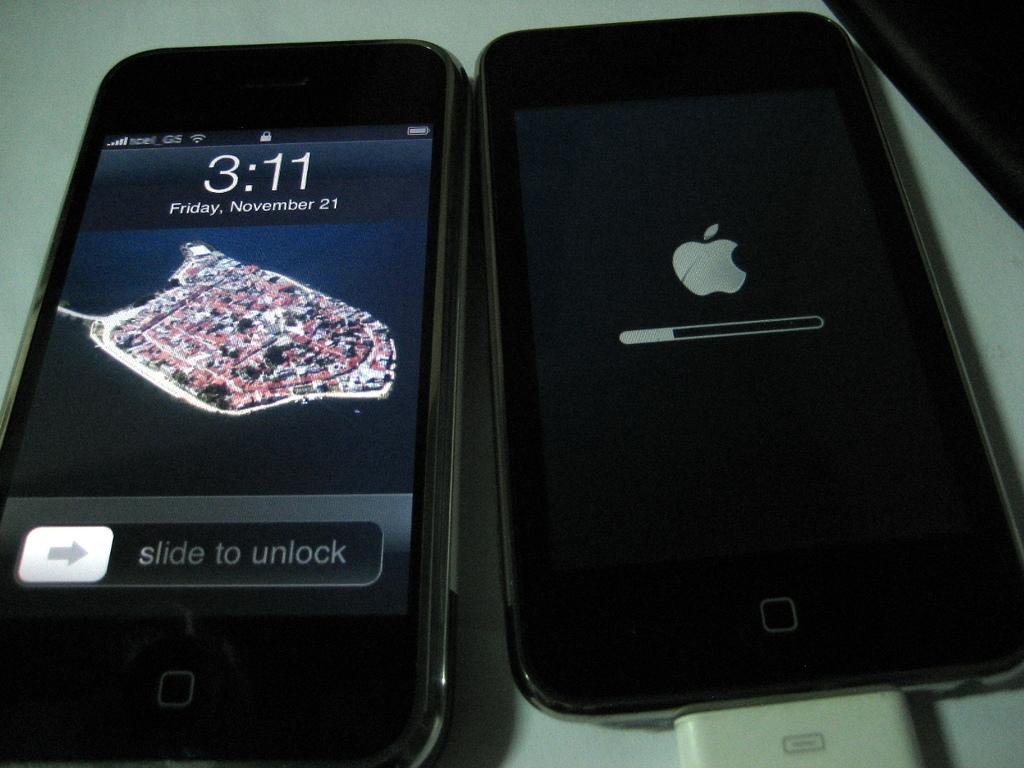What is the brand of phone?
Provide a short and direct response. Answering does not require reading text in the image. What time is it?
Your response must be concise. 3:11. 